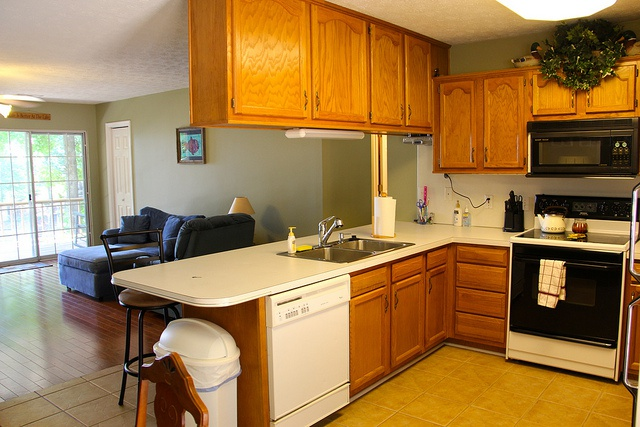Describe the objects in this image and their specific colors. I can see oven in darkgray, black, tan, khaki, and olive tones, microwave in darkgray, black, olive, and brown tones, couch in darkgray, black, gray, and lightblue tones, chair in darkgray, black, maroon, and gray tones, and chair in darkgray, maroon, and brown tones in this image. 